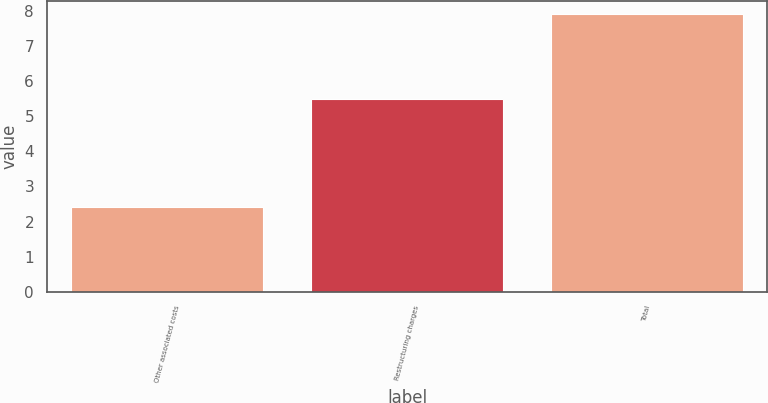Convert chart to OTSL. <chart><loc_0><loc_0><loc_500><loc_500><bar_chart><fcel>Other associated costs<fcel>Restructuring charges<fcel>Total<nl><fcel>2.4<fcel>5.5<fcel>7.9<nl></chart> 